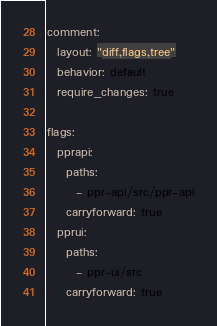Convert code to text. <code><loc_0><loc_0><loc_500><loc_500><_YAML_>
comment:
  layout: "diff,flags,tree"
  behavior: default
  require_changes: true

flags:
  pprapi:
    paths:
      - ppr-api/src/ppr-api
    carryforward: true
  pprui:
    paths:
      - ppr-ui/src
    carryforward: true
</code> 